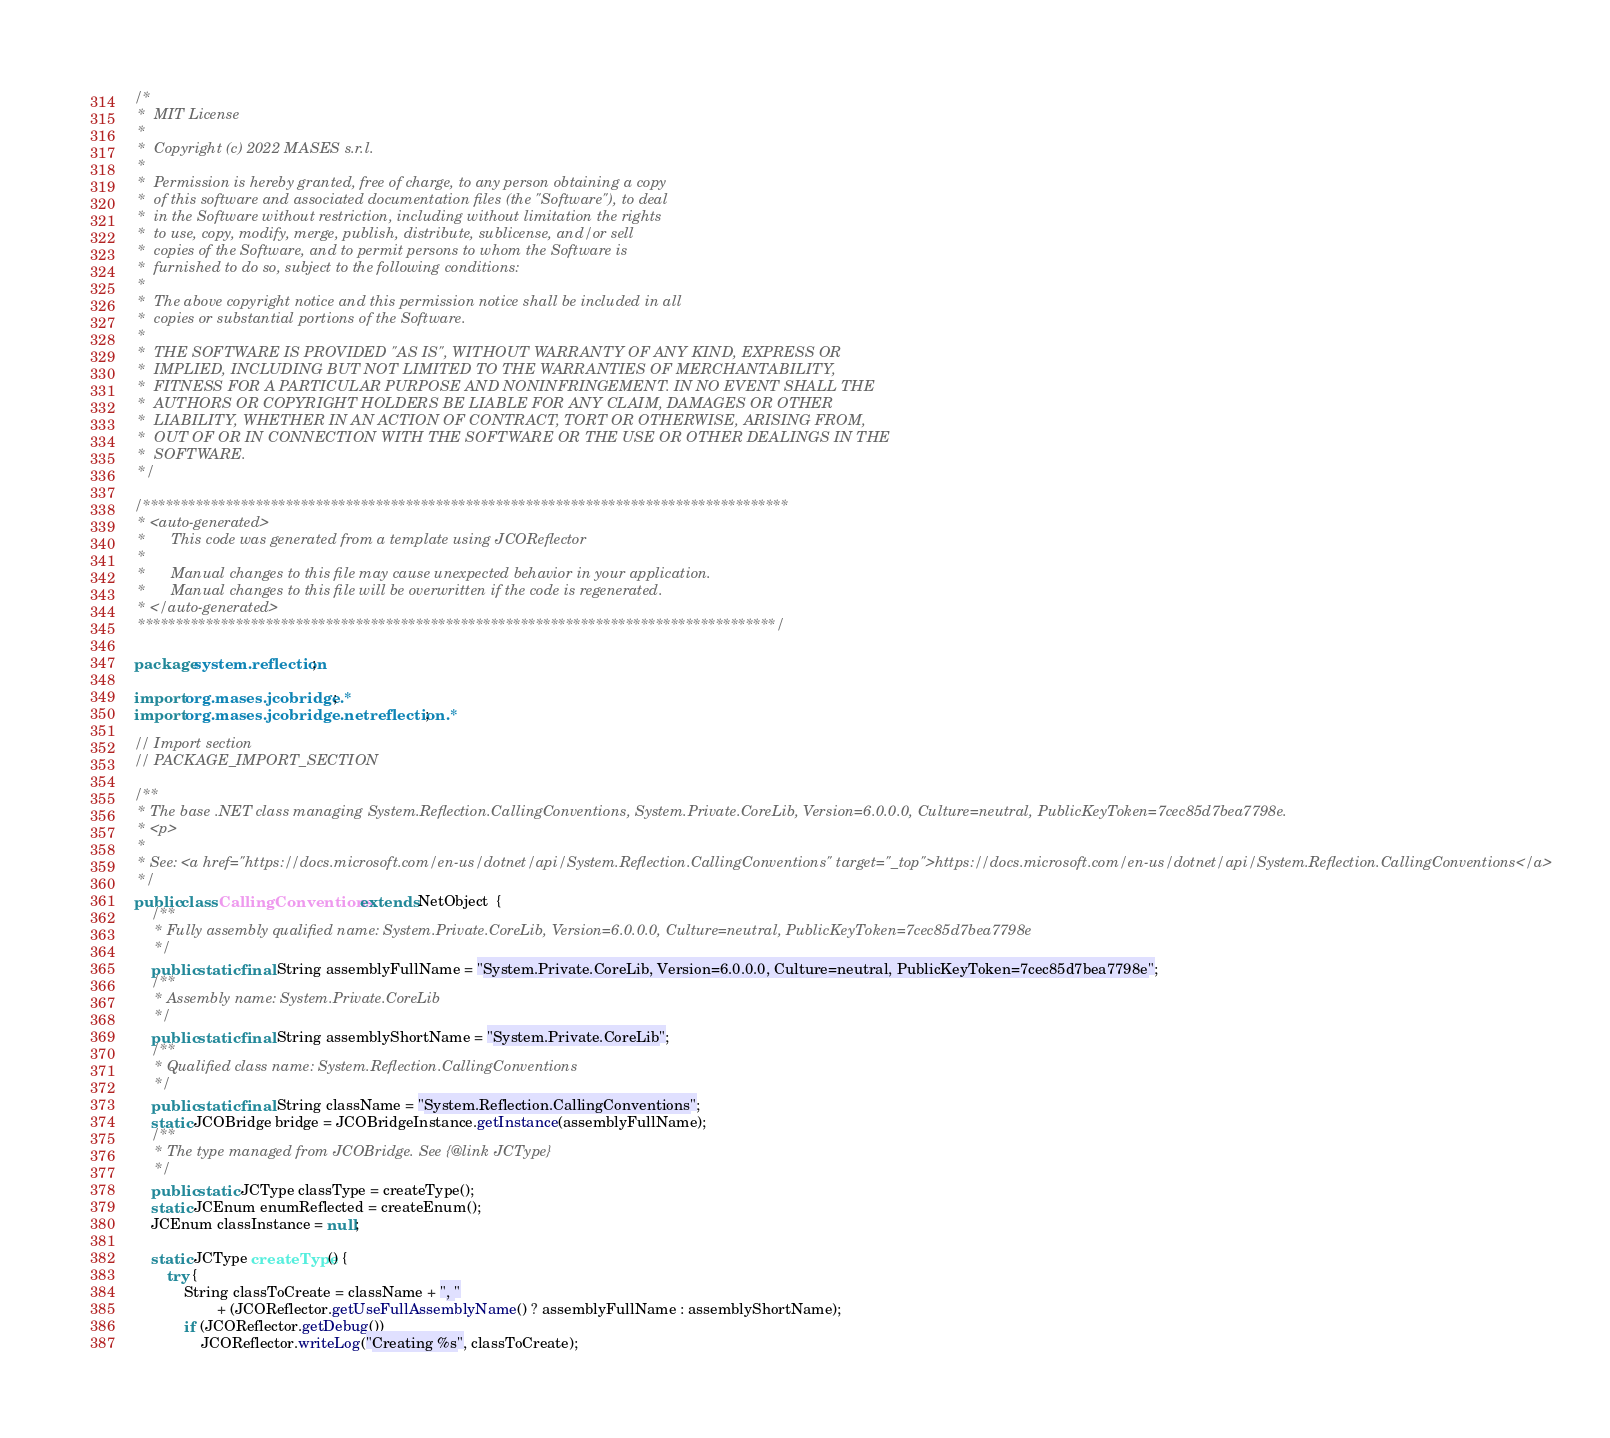Convert code to text. <code><loc_0><loc_0><loc_500><loc_500><_Java_>/*
 *  MIT License
 *
 *  Copyright (c) 2022 MASES s.r.l.
 *
 *  Permission is hereby granted, free of charge, to any person obtaining a copy
 *  of this software and associated documentation files (the "Software"), to deal
 *  in the Software without restriction, including without limitation the rights
 *  to use, copy, modify, merge, publish, distribute, sublicense, and/or sell
 *  copies of the Software, and to permit persons to whom the Software is
 *  furnished to do so, subject to the following conditions:
 *
 *  The above copyright notice and this permission notice shall be included in all
 *  copies or substantial portions of the Software.
 *
 *  THE SOFTWARE IS PROVIDED "AS IS", WITHOUT WARRANTY OF ANY KIND, EXPRESS OR
 *  IMPLIED, INCLUDING BUT NOT LIMITED TO THE WARRANTIES OF MERCHANTABILITY,
 *  FITNESS FOR A PARTICULAR PURPOSE AND NONINFRINGEMENT. IN NO EVENT SHALL THE
 *  AUTHORS OR COPYRIGHT HOLDERS BE LIABLE FOR ANY CLAIM, DAMAGES OR OTHER
 *  LIABILITY, WHETHER IN AN ACTION OF CONTRACT, TORT OR OTHERWISE, ARISING FROM,
 *  OUT OF OR IN CONNECTION WITH THE SOFTWARE OR THE USE OR OTHER DEALINGS IN THE
 *  SOFTWARE.
 */

/**************************************************************************************
 * <auto-generated>
 *      This code was generated from a template using JCOReflector
 * 
 *      Manual changes to this file may cause unexpected behavior in your application.
 *      Manual changes to this file will be overwritten if the code is regenerated.
 * </auto-generated>
 *************************************************************************************/

package system.reflection;

import org.mases.jcobridge.*;
import org.mases.jcobridge.netreflection.*;

// Import section
// PACKAGE_IMPORT_SECTION

/**
 * The base .NET class managing System.Reflection.CallingConventions, System.Private.CoreLib, Version=6.0.0.0, Culture=neutral, PublicKeyToken=7cec85d7bea7798e.
 * <p>
 * 
 * See: <a href="https://docs.microsoft.com/en-us/dotnet/api/System.Reflection.CallingConventions" target="_top">https://docs.microsoft.com/en-us/dotnet/api/System.Reflection.CallingConventions</a>
 */
public class CallingConventions extends NetObject  {
    /**
     * Fully assembly qualified name: System.Private.CoreLib, Version=6.0.0.0, Culture=neutral, PublicKeyToken=7cec85d7bea7798e
     */
    public static final String assemblyFullName = "System.Private.CoreLib, Version=6.0.0.0, Culture=neutral, PublicKeyToken=7cec85d7bea7798e";
    /**
     * Assembly name: System.Private.CoreLib
     */
    public static final String assemblyShortName = "System.Private.CoreLib";
    /**
     * Qualified class name: System.Reflection.CallingConventions
     */
    public static final String className = "System.Reflection.CallingConventions";
    static JCOBridge bridge = JCOBridgeInstance.getInstance(assemblyFullName);
    /**
     * The type managed from JCOBridge. See {@link JCType}
     */
    public static JCType classType = createType();
    static JCEnum enumReflected = createEnum();
    JCEnum classInstance = null;

    static JCType createType() {
        try {
            String classToCreate = className + ", "
                    + (JCOReflector.getUseFullAssemblyName() ? assemblyFullName : assemblyShortName);
            if (JCOReflector.getDebug())
                JCOReflector.writeLog("Creating %s", classToCreate);</code> 